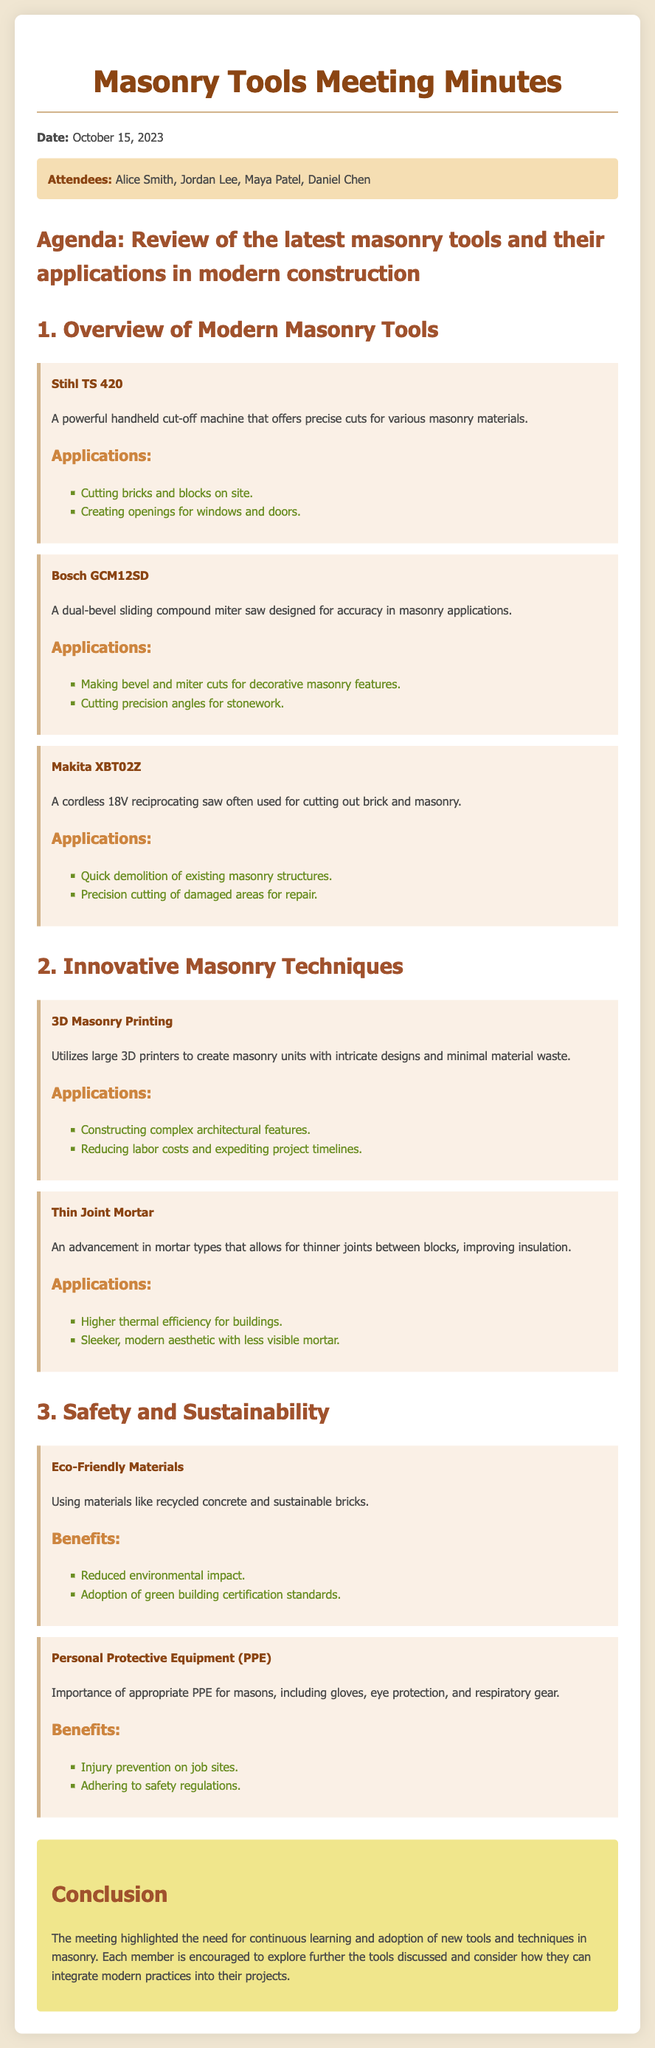What is the date of the meeting? The meeting took place on October 15, 2023, as stated in the document.
Answer: October 15, 2023 Who are the attendees of the meeting? The attendees listed in the document are Alice Smith, Jordan Lee, Maya Patel, and Daniel Chen.
Answer: Alice Smith, Jordan Lee, Maya Patel, Daniel Chen What is the first masonry tool discussed? The first tool mentioned in the document is the Stihl TS 420, which is noted for its capabilities.
Answer: Stihl TS 420 What is one application of the Bosch GCM12SD? The document mentions making bevel and miter cuts for decorative masonry features as one application.
Answer: Making bevel and miter cuts What innovative technique utilizes large 3D printers? The technique mentioned that employs large 3D printers is 3D Masonry Printing, which allows for intricate designs.
Answer: 3D Masonry Printing What benefits do eco-friendly materials offer? The document states benefits including reduced environmental impact and adherence to green building certification standards.
Answer: Reduced environmental impact What kind of mortar advancement is discussed? Thin Joint Mortar is highlighted as an advancement that improves insulation through thinner joints.
Answer: Thin Joint Mortar What is emphasized about Personal Protective Equipment (PPE)? The document emphasizes the importance of appropriate PPE for injury prevention and safety regulation adherence.
Answer: Injury prevention What is the conclusion of the meeting? The conclusion reflects on the need for continuous learning and adoption of new tools and techniques in masonry.
Answer: Continuous learning and adoption of new tools 